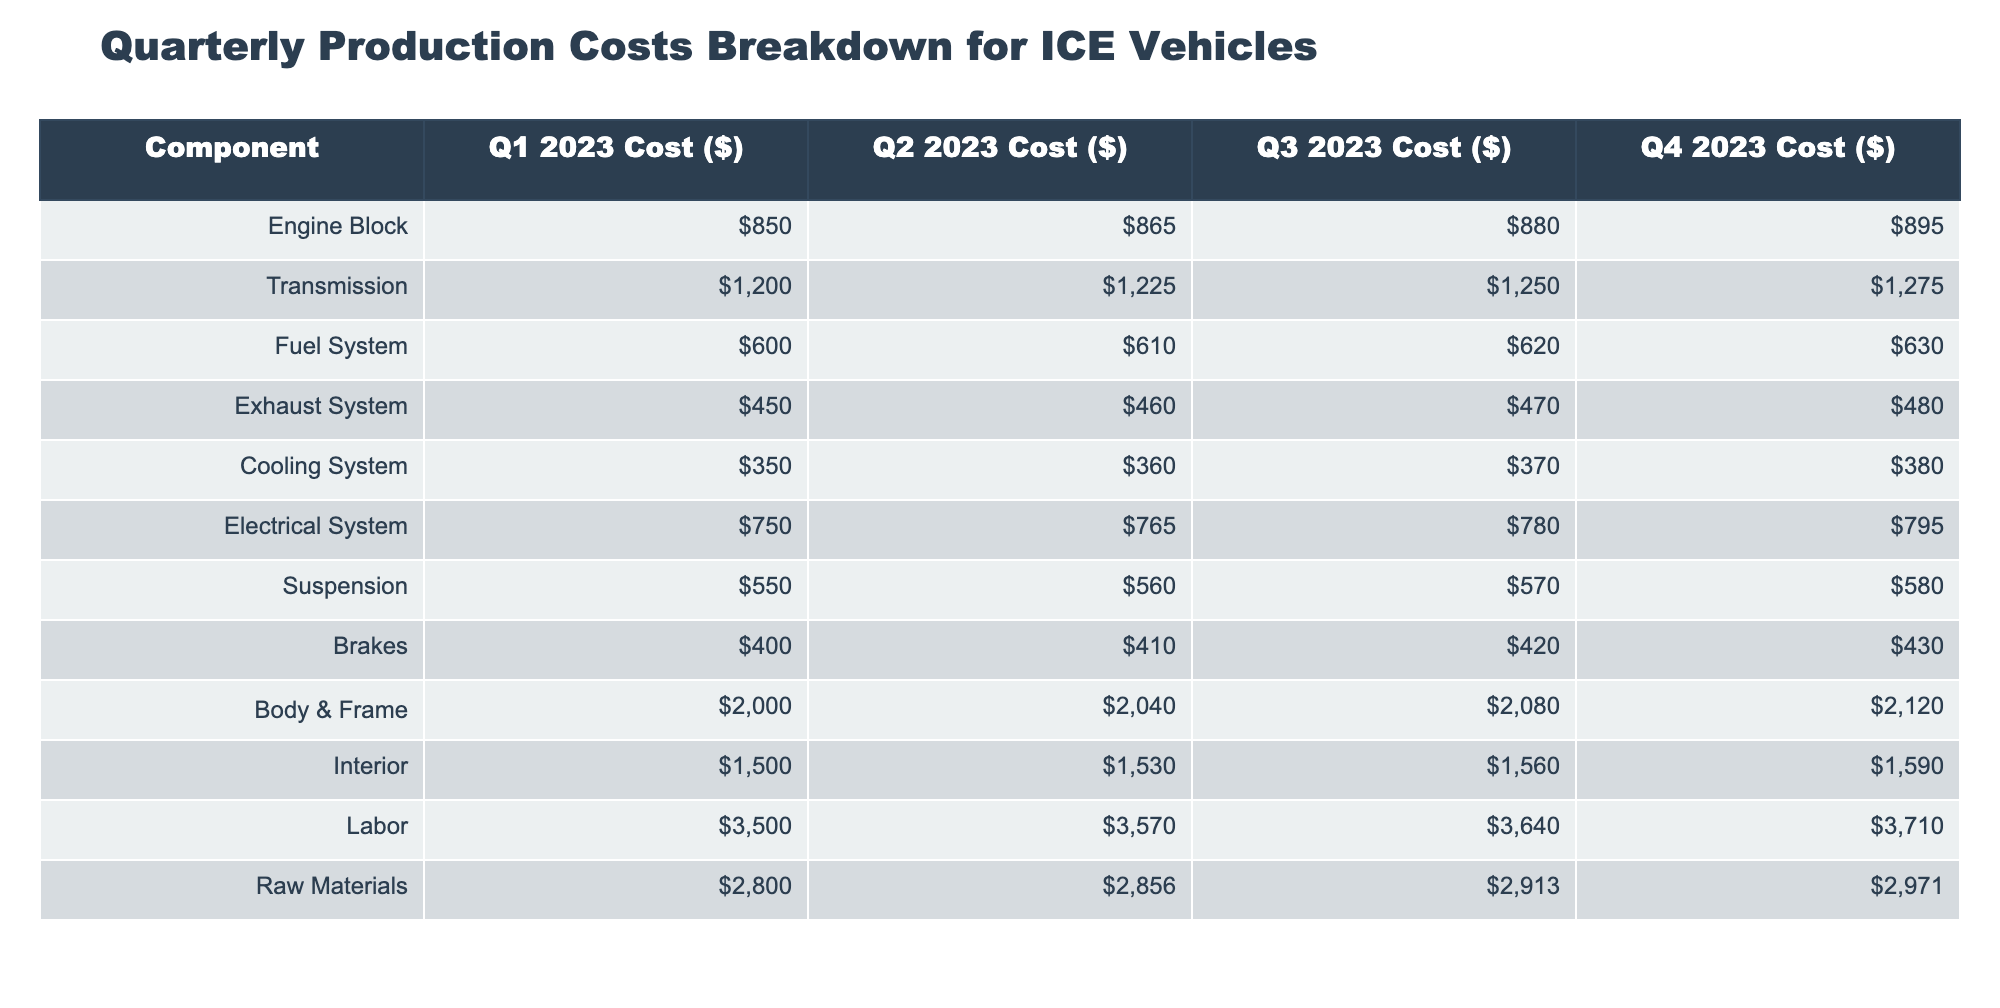What is the cost of the Engine Block in Q3 2023? The table shows that the cost of the Engine Block in Q3 2023 is listed directly under the "Q3 2023 Cost ($)" column in the row for "Engine Block". According to the data, it is 880.
Answer: 880 What is the total labor cost across all four quarters? To find the total labor cost across all quarters, we need to sum the values in the "Labor" row: 3500 + 3570 + 3640 + 3710. Doing this gives us 3500 + 3570 = 7070, 7070 + 3640 = 10710, and 10710 + 3710 = 14420.
Answer: 14420 Is the cost of the Transmission in Q1 2023 greater than the cost of the Cooling System in the same quarter? In Q1 2023, the Transmission cost is 1200 and the Cooling System cost is 350. Since 1200 is greater than 350, the statement is true.
Answer: Yes What is the average cost of the Fuel System across the four quarters? First, we sum the values for the Fuel System: 600 + 610 + 620 + 630 = 2460. Then, we divide this sum by the number of quarters, which is 4: 2460 / 4 = 615.
Answer: 615 Which component has the highest cost in Q4 2023? We need to compare the costs of all components in the "Q4 2023 Cost ($)" column. The highest value is found in the Body & Frame row, which is 2120. Other components have lower costs.
Answer: Body & Frame By how much did the cost of the Electrical System increase from Q1 to Q4 2023? To find the increase, we take the Q4 cost of the Electrical System (795) and subtract the Q1 cost (750): 795 - 750 = 45. Therefore, the cost increased by 45.
Answer: 45 Is the total cost of Interior and Labor in Q2 2023 greater than 5000? The cost of Interior in Q2 2023 is 1530 and the Labor cost is 3570. Adding these together gives us 1530 + 3570 = 5100, which is indeed greater than 5000.
Answer: Yes What is the percent increase of the Cooling System cost from Q1 to Q4 2023? The Q1 cost of the Cooling System is 350 and the Q4 cost is 380. To find the percent increase, we first calculate the increase: 380 - 350 = 30. Then, we divide this increase by the original cost and multiply by 100: (30 / 350) * 100 = 8.57%.
Answer: 8.57% 